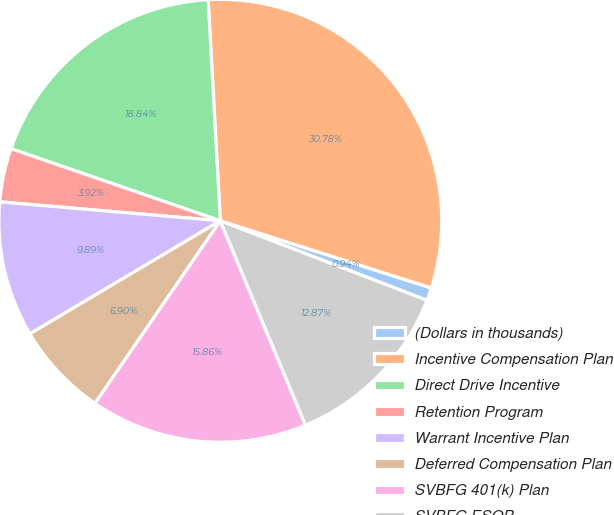Convert chart to OTSL. <chart><loc_0><loc_0><loc_500><loc_500><pie_chart><fcel>(Dollars in thousands)<fcel>Incentive Compensation Plan<fcel>Direct Drive Incentive<fcel>Retention Program<fcel>Warrant Incentive Plan<fcel>Deferred Compensation Plan<fcel>SVBFG 401(k) Plan<fcel>SVBFG ESOP<nl><fcel>0.94%<fcel>30.78%<fcel>18.84%<fcel>3.92%<fcel>9.89%<fcel>6.9%<fcel>15.86%<fcel>12.87%<nl></chart> 